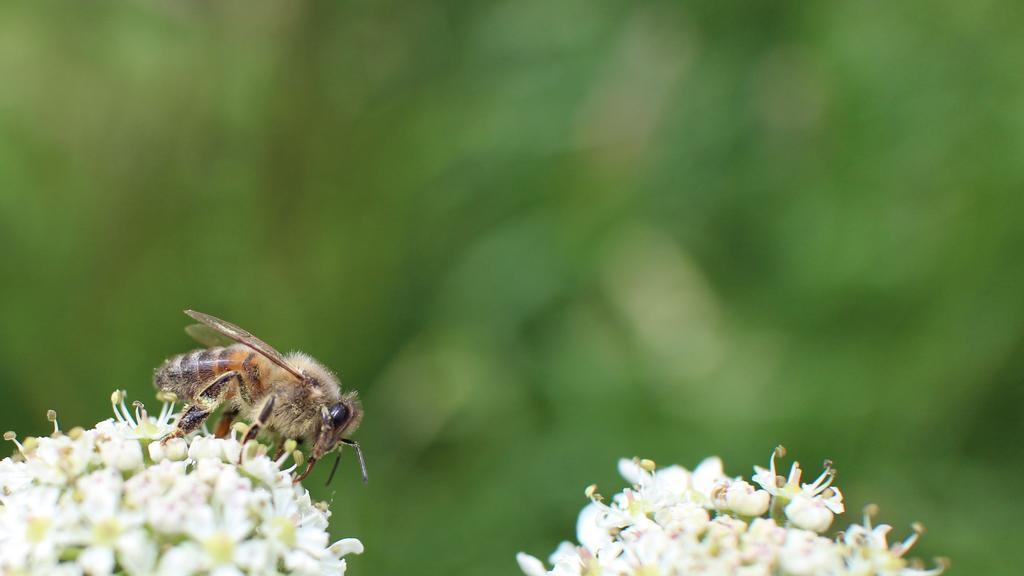Describe this image in one or two sentences. On the left there is an insect on a flower and beside it there is another flower. In the background the image is blur. 